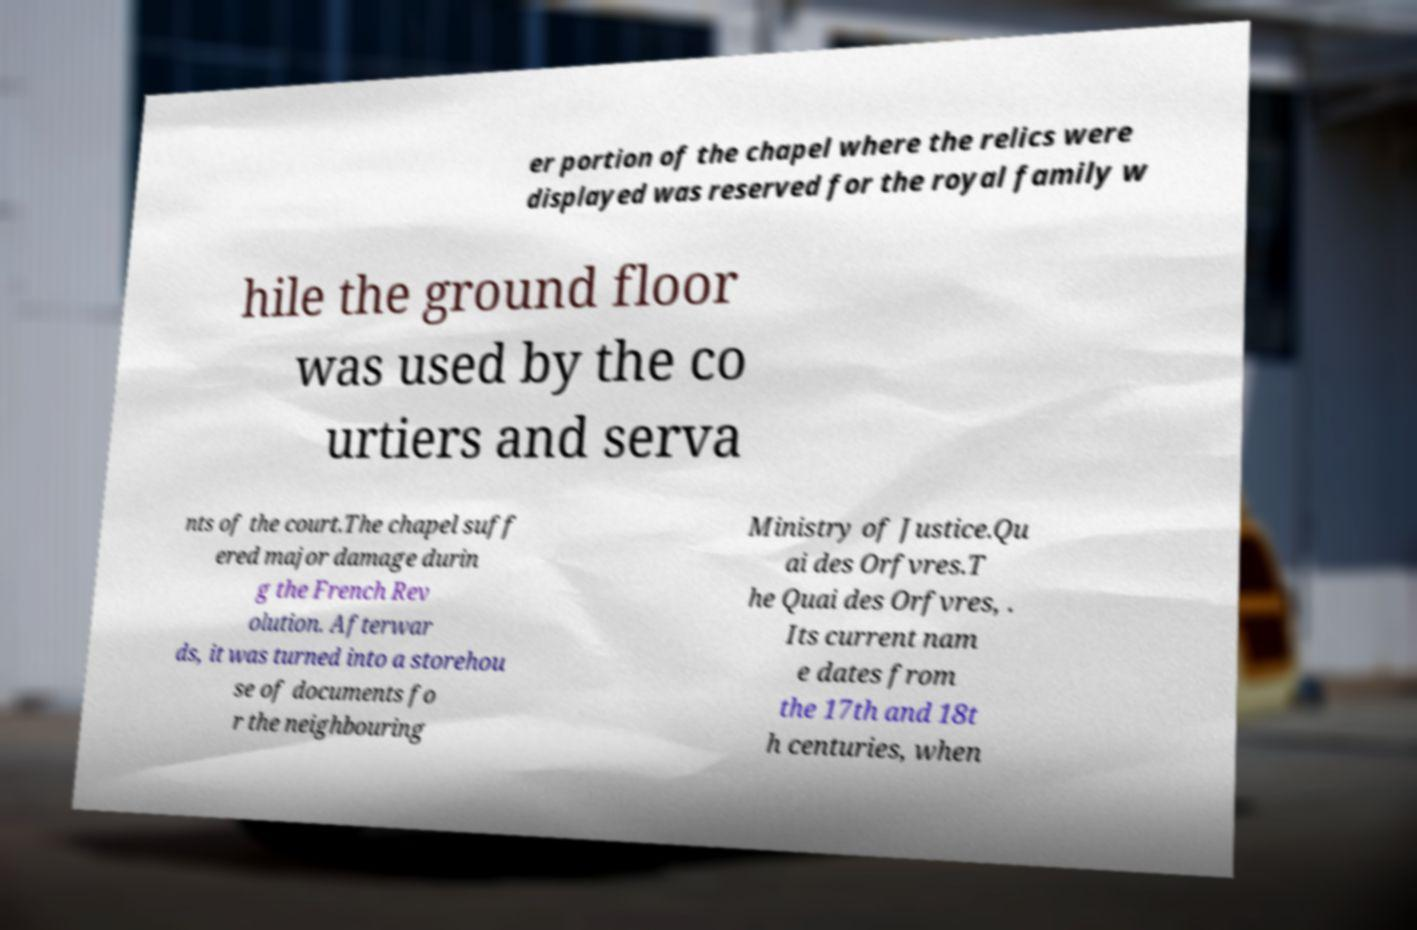Can you accurately transcribe the text from the provided image for me? er portion of the chapel where the relics were displayed was reserved for the royal family w hile the ground floor was used by the co urtiers and serva nts of the court.The chapel suff ered major damage durin g the French Rev olution. Afterwar ds, it was turned into a storehou se of documents fo r the neighbouring Ministry of Justice.Qu ai des Orfvres.T he Quai des Orfvres, . Its current nam e dates from the 17th and 18t h centuries, when 